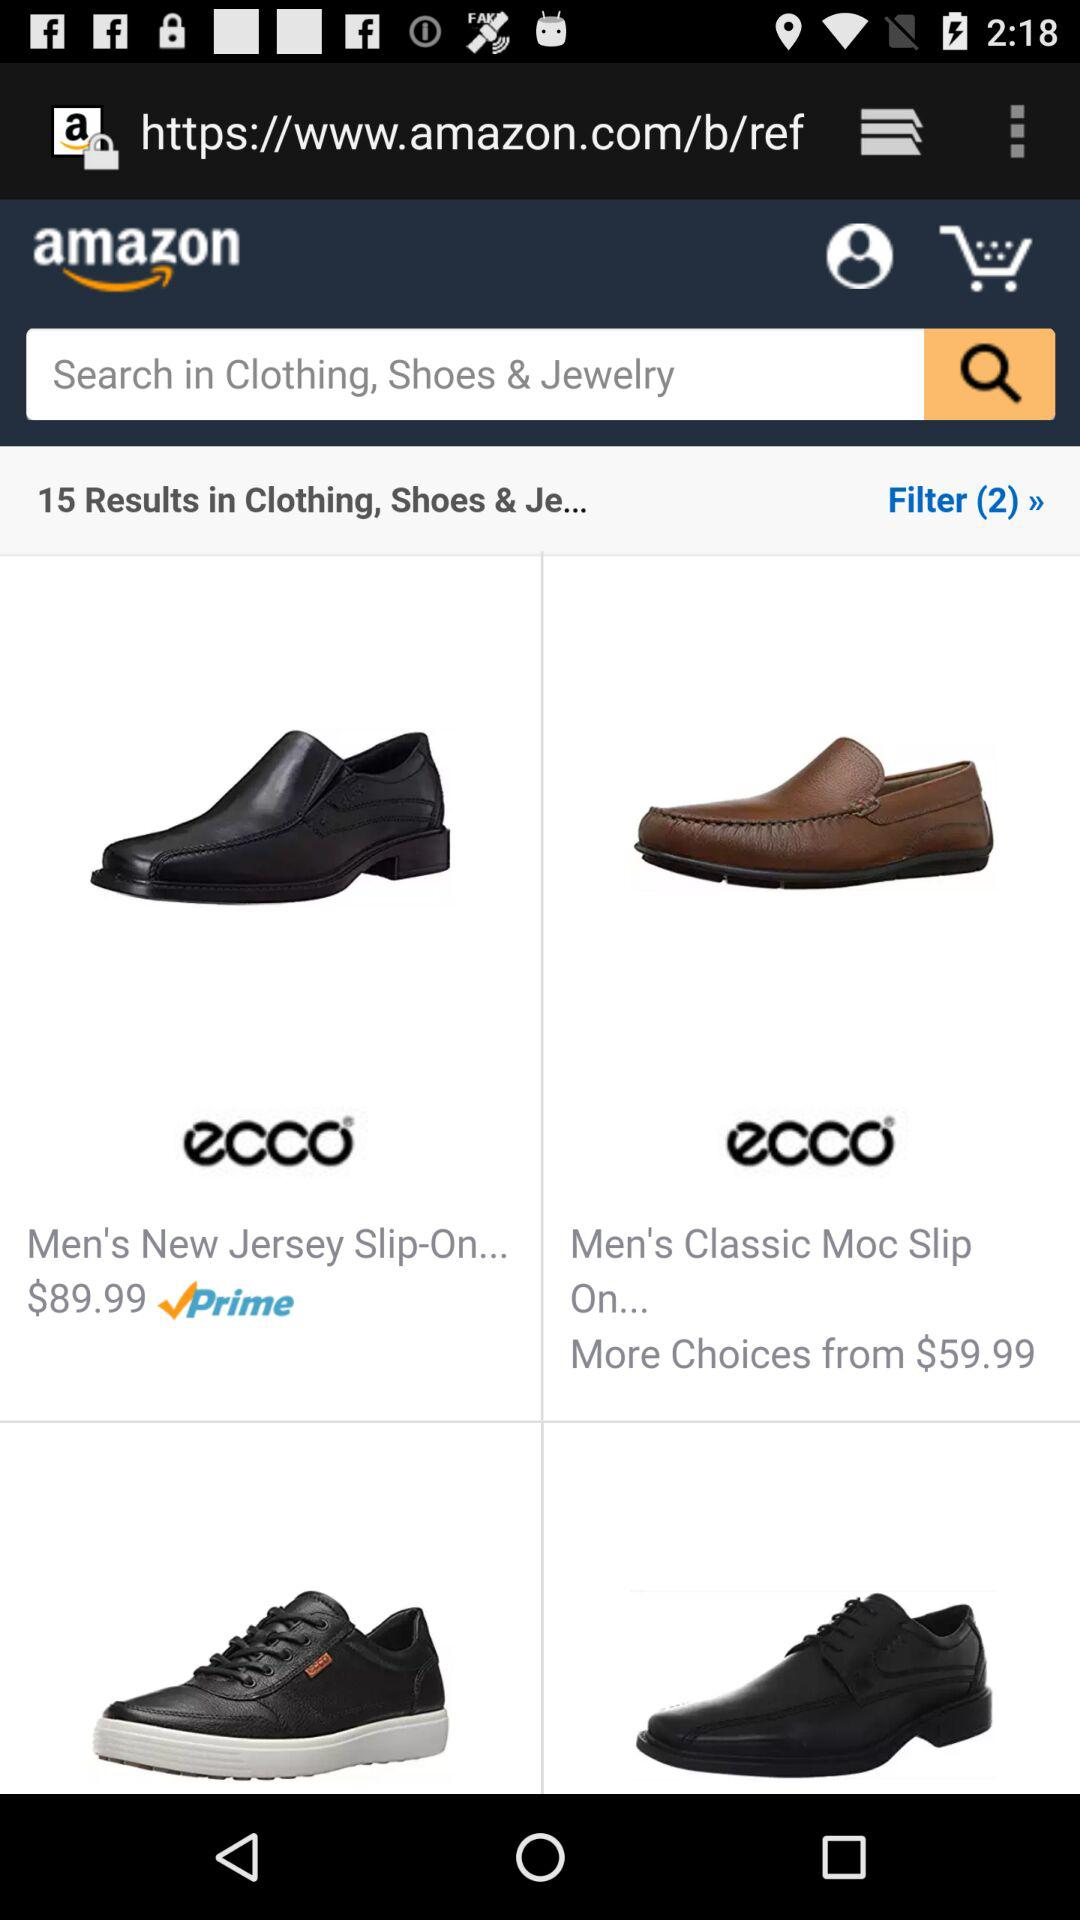How many results are shown for the search query?
Answer the question using a single word or phrase. 15 